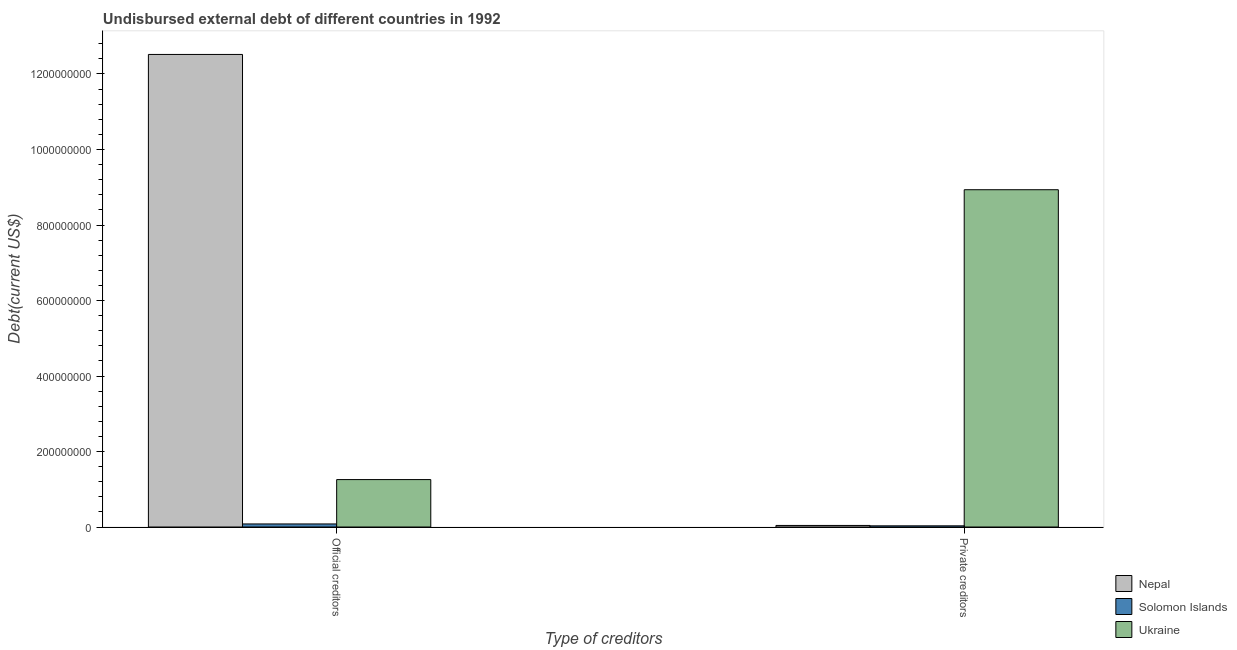How many groups of bars are there?
Give a very brief answer. 2. Are the number of bars per tick equal to the number of legend labels?
Provide a succinct answer. Yes. How many bars are there on the 1st tick from the left?
Give a very brief answer. 3. How many bars are there on the 2nd tick from the right?
Your answer should be compact. 3. What is the label of the 1st group of bars from the left?
Your response must be concise. Official creditors. What is the undisbursed external debt of private creditors in Ukraine?
Your answer should be compact. 8.93e+08. Across all countries, what is the maximum undisbursed external debt of official creditors?
Give a very brief answer. 1.25e+09. Across all countries, what is the minimum undisbursed external debt of private creditors?
Keep it short and to the point. 3.13e+06. In which country was the undisbursed external debt of private creditors maximum?
Make the answer very short. Ukraine. In which country was the undisbursed external debt of private creditors minimum?
Your answer should be compact. Solomon Islands. What is the total undisbursed external debt of private creditors in the graph?
Give a very brief answer. 9.01e+08. What is the difference between the undisbursed external debt of official creditors in Ukraine and that in Nepal?
Offer a very short reply. -1.13e+09. What is the difference between the undisbursed external debt of official creditors in Solomon Islands and the undisbursed external debt of private creditors in Nepal?
Your response must be concise. 3.99e+06. What is the average undisbursed external debt of official creditors per country?
Make the answer very short. 4.62e+08. What is the difference between the undisbursed external debt of official creditors and undisbursed external debt of private creditors in Ukraine?
Offer a terse response. -7.68e+08. What is the ratio of the undisbursed external debt of official creditors in Ukraine to that in Nepal?
Offer a terse response. 0.1. What does the 3rd bar from the left in Private creditors represents?
Your answer should be very brief. Ukraine. What does the 3rd bar from the right in Official creditors represents?
Give a very brief answer. Nepal. Are all the bars in the graph horizontal?
Give a very brief answer. No. Are the values on the major ticks of Y-axis written in scientific E-notation?
Your response must be concise. No. Does the graph contain any zero values?
Your answer should be very brief. No. Does the graph contain grids?
Provide a succinct answer. No. How are the legend labels stacked?
Your answer should be compact. Vertical. What is the title of the graph?
Your response must be concise. Undisbursed external debt of different countries in 1992. What is the label or title of the X-axis?
Provide a succinct answer. Type of creditors. What is the label or title of the Y-axis?
Your answer should be very brief. Debt(current US$). What is the Debt(current US$) of Nepal in Official creditors?
Offer a terse response. 1.25e+09. What is the Debt(current US$) in Solomon Islands in Official creditors?
Offer a very short reply. 8.13e+06. What is the Debt(current US$) of Ukraine in Official creditors?
Offer a very short reply. 1.26e+08. What is the Debt(current US$) in Nepal in Private creditors?
Your answer should be compact. 4.14e+06. What is the Debt(current US$) of Solomon Islands in Private creditors?
Your response must be concise. 3.13e+06. What is the Debt(current US$) in Ukraine in Private creditors?
Provide a succinct answer. 8.93e+08. Across all Type of creditors, what is the maximum Debt(current US$) of Nepal?
Keep it short and to the point. 1.25e+09. Across all Type of creditors, what is the maximum Debt(current US$) of Solomon Islands?
Ensure brevity in your answer.  8.13e+06. Across all Type of creditors, what is the maximum Debt(current US$) of Ukraine?
Offer a very short reply. 8.93e+08. Across all Type of creditors, what is the minimum Debt(current US$) of Nepal?
Provide a short and direct response. 4.14e+06. Across all Type of creditors, what is the minimum Debt(current US$) of Solomon Islands?
Give a very brief answer. 3.13e+06. Across all Type of creditors, what is the minimum Debt(current US$) of Ukraine?
Provide a short and direct response. 1.26e+08. What is the total Debt(current US$) of Nepal in the graph?
Offer a terse response. 1.26e+09. What is the total Debt(current US$) of Solomon Islands in the graph?
Provide a short and direct response. 1.13e+07. What is the total Debt(current US$) in Ukraine in the graph?
Offer a very short reply. 1.02e+09. What is the difference between the Debt(current US$) of Nepal in Official creditors and that in Private creditors?
Offer a terse response. 1.25e+09. What is the difference between the Debt(current US$) of Solomon Islands in Official creditors and that in Private creditors?
Provide a succinct answer. 4.99e+06. What is the difference between the Debt(current US$) of Ukraine in Official creditors and that in Private creditors?
Offer a very short reply. -7.68e+08. What is the difference between the Debt(current US$) of Nepal in Official creditors and the Debt(current US$) of Solomon Islands in Private creditors?
Give a very brief answer. 1.25e+09. What is the difference between the Debt(current US$) of Nepal in Official creditors and the Debt(current US$) of Ukraine in Private creditors?
Provide a short and direct response. 3.58e+08. What is the difference between the Debt(current US$) in Solomon Islands in Official creditors and the Debt(current US$) in Ukraine in Private creditors?
Ensure brevity in your answer.  -8.85e+08. What is the average Debt(current US$) in Nepal per Type of creditors?
Offer a very short reply. 6.28e+08. What is the average Debt(current US$) of Solomon Islands per Type of creditors?
Your response must be concise. 5.63e+06. What is the average Debt(current US$) in Ukraine per Type of creditors?
Give a very brief answer. 5.10e+08. What is the difference between the Debt(current US$) of Nepal and Debt(current US$) of Solomon Islands in Official creditors?
Ensure brevity in your answer.  1.24e+09. What is the difference between the Debt(current US$) of Nepal and Debt(current US$) of Ukraine in Official creditors?
Your answer should be very brief. 1.13e+09. What is the difference between the Debt(current US$) in Solomon Islands and Debt(current US$) in Ukraine in Official creditors?
Your answer should be very brief. -1.18e+08. What is the difference between the Debt(current US$) in Nepal and Debt(current US$) in Solomon Islands in Private creditors?
Your answer should be very brief. 1.00e+06. What is the difference between the Debt(current US$) in Nepal and Debt(current US$) in Ukraine in Private creditors?
Provide a succinct answer. -8.89e+08. What is the difference between the Debt(current US$) of Solomon Islands and Debt(current US$) of Ukraine in Private creditors?
Provide a succinct answer. -8.90e+08. What is the ratio of the Debt(current US$) in Nepal in Official creditors to that in Private creditors?
Keep it short and to the point. 302.72. What is the ratio of the Debt(current US$) of Solomon Islands in Official creditors to that in Private creditors?
Your answer should be very brief. 2.59. What is the ratio of the Debt(current US$) in Ukraine in Official creditors to that in Private creditors?
Offer a very short reply. 0.14. What is the difference between the highest and the second highest Debt(current US$) of Nepal?
Your response must be concise. 1.25e+09. What is the difference between the highest and the second highest Debt(current US$) in Solomon Islands?
Your response must be concise. 4.99e+06. What is the difference between the highest and the second highest Debt(current US$) in Ukraine?
Offer a terse response. 7.68e+08. What is the difference between the highest and the lowest Debt(current US$) in Nepal?
Ensure brevity in your answer.  1.25e+09. What is the difference between the highest and the lowest Debt(current US$) in Solomon Islands?
Offer a very short reply. 4.99e+06. What is the difference between the highest and the lowest Debt(current US$) in Ukraine?
Give a very brief answer. 7.68e+08. 